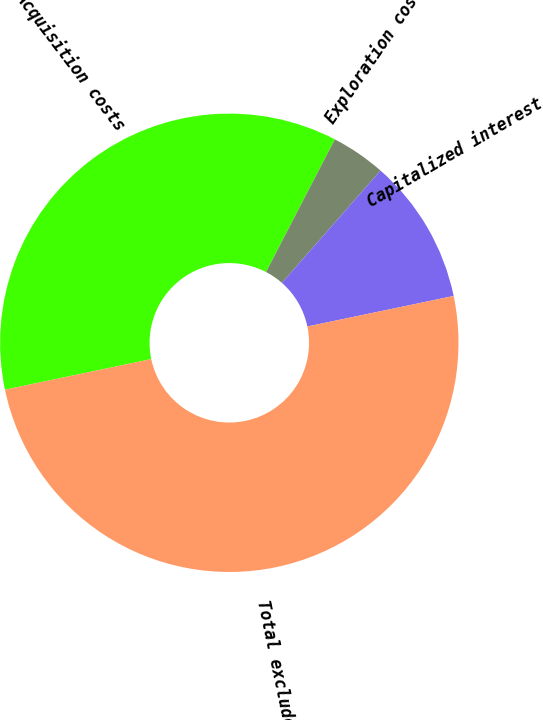Convert chart to OTSL. <chart><loc_0><loc_0><loc_500><loc_500><pie_chart><fcel>Acquisition costs<fcel>Exploration costs<fcel>Capitalized interest<fcel>Total excluded costs<nl><fcel>35.9%<fcel>3.85%<fcel>10.26%<fcel>50.0%<nl></chart> 